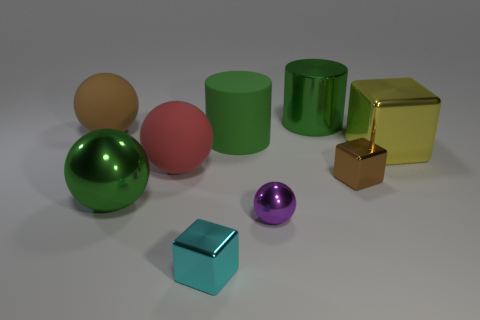There is a green metal thing behind the tiny brown thing; is its shape the same as the big green rubber thing?
Your response must be concise. Yes. What is the green object behind the big green rubber cylinder made of?
Make the answer very short. Metal. The big matte object that is on the left side of the big matte ball right of the brown rubber ball is what shape?
Make the answer very short. Sphere. There is a yellow object; is it the same shape as the brown thing in front of the big green rubber cylinder?
Your response must be concise. Yes. What number of metallic cylinders are right of the brown object that is left of the tiny purple thing?
Offer a terse response. 1. There is a brown object that is the same shape as the large red rubber object; what is its material?
Your response must be concise. Rubber. What number of green things are matte things or small matte things?
Your answer should be compact. 1. Is there anything else of the same color as the metallic cylinder?
Give a very brief answer. Yes. What color is the large cylinder that is behind the brown sphere on the left side of the small purple metal sphere?
Offer a very short reply. Green. Is the number of big metal cylinders to the left of the small cyan object less than the number of brown cubes to the right of the small purple shiny object?
Your answer should be very brief. Yes. 